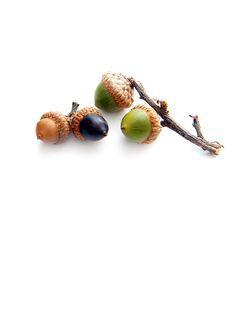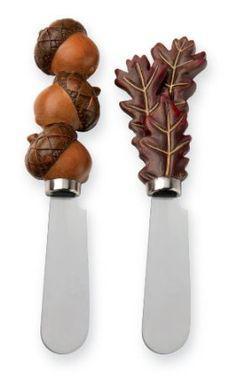The first image is the image on the left, the second image is the image on the right. Analyze the images presented: Is the assertion "The left image contains exactly three brown acorns with their caps on." valid? Answer yes or no. No. 